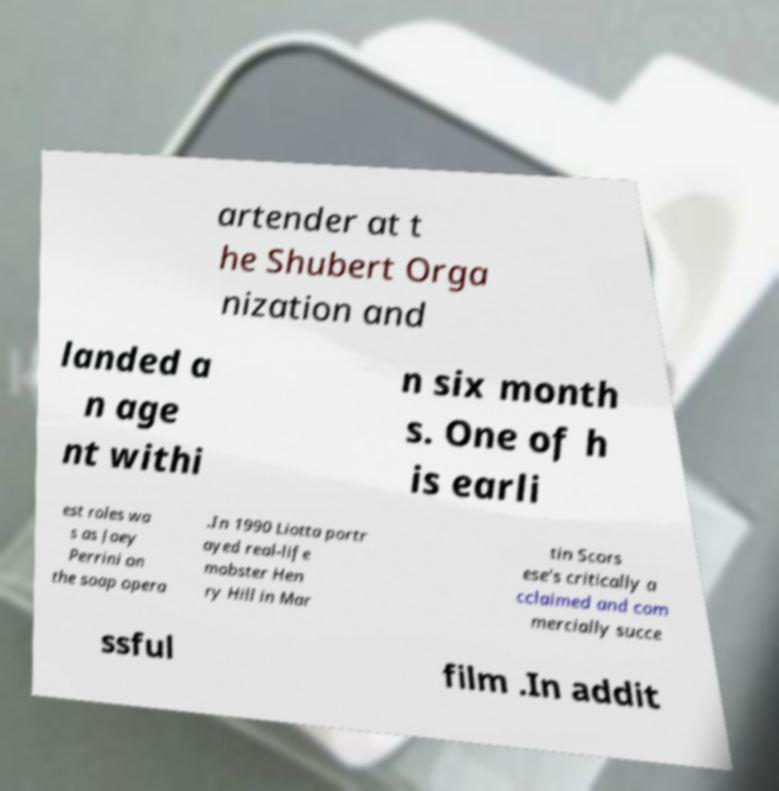What messages or text are displayed in this image? I need them in a readable, typed format. artender at t he Shubert Orga nization and landed a n age nt withi n six month s. One of h is earli est roles wa s as Joey Perrini on the soap opera .In 1990 Liotta portr ayed real-life mobster Hen ry Hill in Mar tin Scors ese's critically a cclaimed and com mercially succe ssful film .In addit 